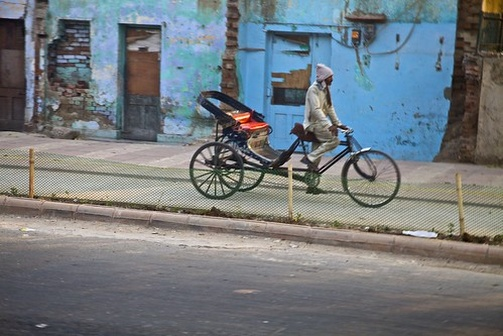Imagine the conversation between the man and a curious passerby who inquires about his tricycle. Passerby: 'Hello! That’s an interesting tricycle you have there. What do you use it for?' 
Man: 'Thank you! It’s quite handy. I use it to make deliveries around the town. The basket at the back is perfect for carrying all sorts of items.' 
Passerby: 'That’s wonderful! It’s great to see something so unique and practical being used.' 
Man: 'Yes, it really is. Plus, it’s good exercise and I get to enjoy the fresh air.' 